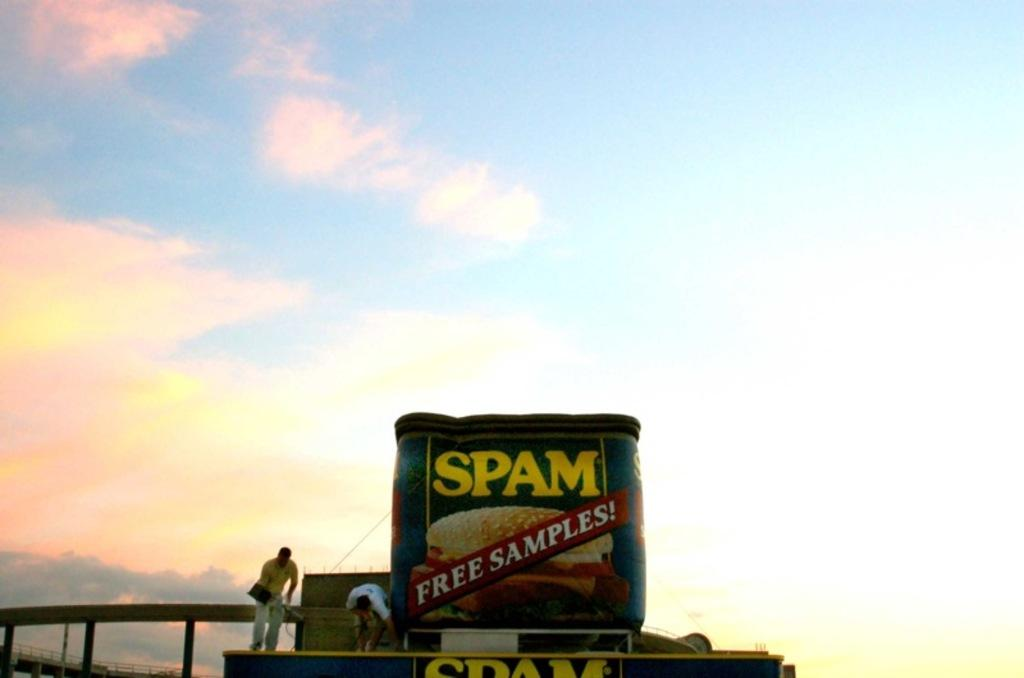<image>
Render a clear and concise summary of the photo. Workmen are on top of a roof with signs for Spam. 